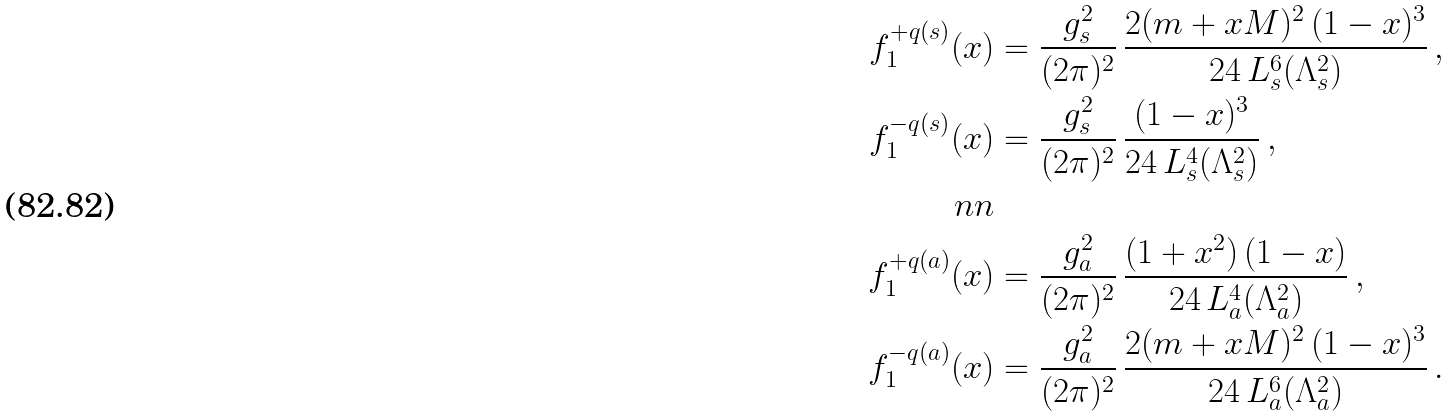<formula> <loc_0><loc_0><loc_500><loc_500>f _ { 1 } ^ { + q ( s ) } ( x ) & = \frac { g _ { s } ^ { 2 } } { ( 2 \pi ) ^ { 2 } } \, \frac { 2 ( m + x M ) ^ { 2 } \, ( 1 - x ) ^ { 3 } } { 2 4 \, L _ { s } ^ { 6 } ( \Lambda _ { s } ^ { 2 } ) } \, , \\ f _ { 1 } ^ { - q ( s ) } ( x ) & = \frac { g _ { s } ^ { 2 } } { ( 2 \pi ) ^ { 2 } } \, \frac { ( 1 - x ) ^ { 3 } } { 2 4 \, L _ { s } ^ { 4 } ( \Lambda _ { s } ^ { 2 } ) } \, , \\ \ n n \\ f _ { 1 } ^ { + q ( a ) } ( x ) & = \frac { g _ { a } ^ { 2 } } { ( 2 \pi ) ^ { 2 } } \, \frac { ( 1 + x ^ { 2 } ) \, ( 1 - x ) } { 2 4 \, L _ { a } ^ { 4 } ( \Lambda _ { a } ^ { 2 } ) } \, , \\ f _ { 1 } ^ { - q ( a ) } ( x ) & = \frac { g _ { a } ^ { 2 } } { ( 2 \pi ) ^ { 2 } } \, \frac { 2 ( m + x M ) ^ { 2 } \, ( 1 - x ) ^ { 3 } } { 2 4 \, L _ { a } ^ { 6 } ( \Lambda _ { a } ^ { 2 } ) } \, . \\</formula> 